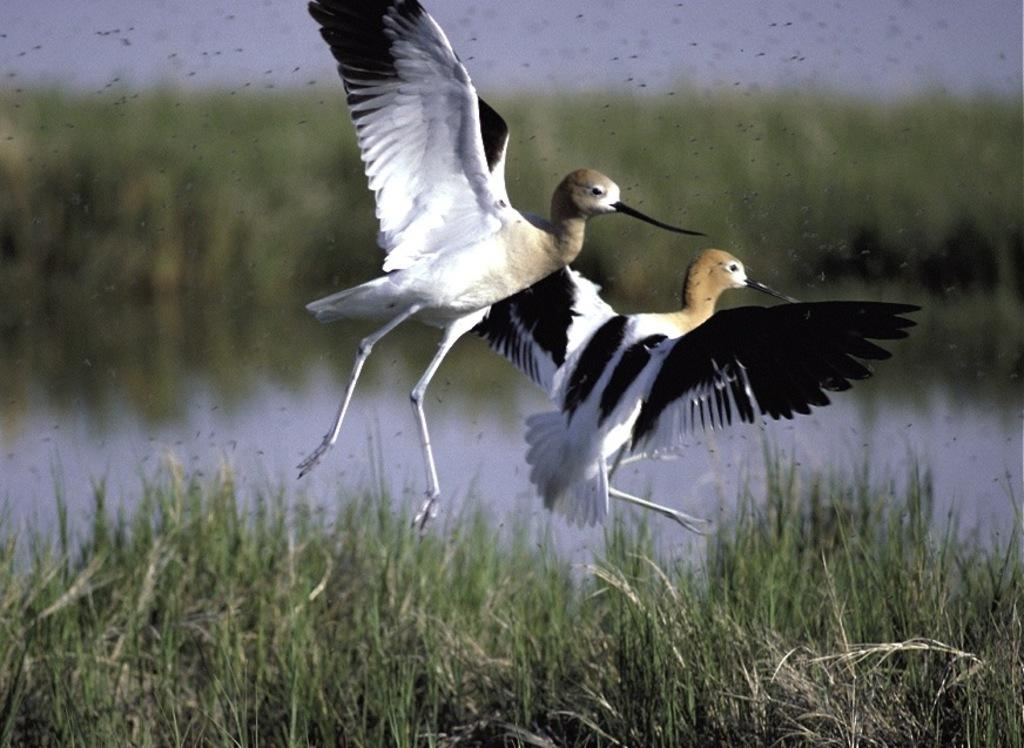What is happening in the center of the image? There are two flying birds in the center of the image. What type of environment is depicted in the image? There is greenery in the image, suggesting a natural setting. What can be seen in the background of the image? There is water visible in the background of the image. How many giants are holding the doll in the image? There are no giants or dolls present in the image. 